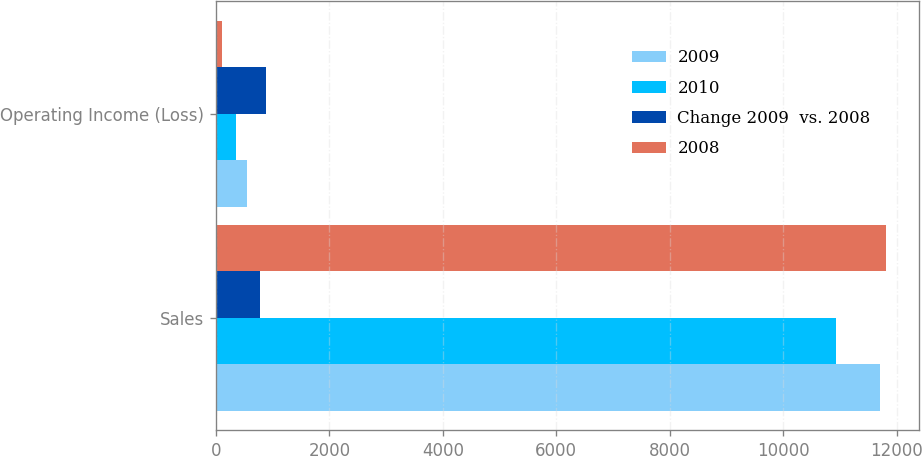<chart> <loc_0><loc_0><loc_500><loc_500><stacked_bar_chart><ecel><fcel>Sales<fcel>Operating Income (Loss)<nl><fcel>2009<fcel>11707<fcel>542<nl><fcel>2010<fcel>10937<fcel>346<nl><fcel>Change 2009  vs. 2008<fcel>770<fcel>888<nl><fcel>2008<fcel>11806<fcel>106<nl></chart> 